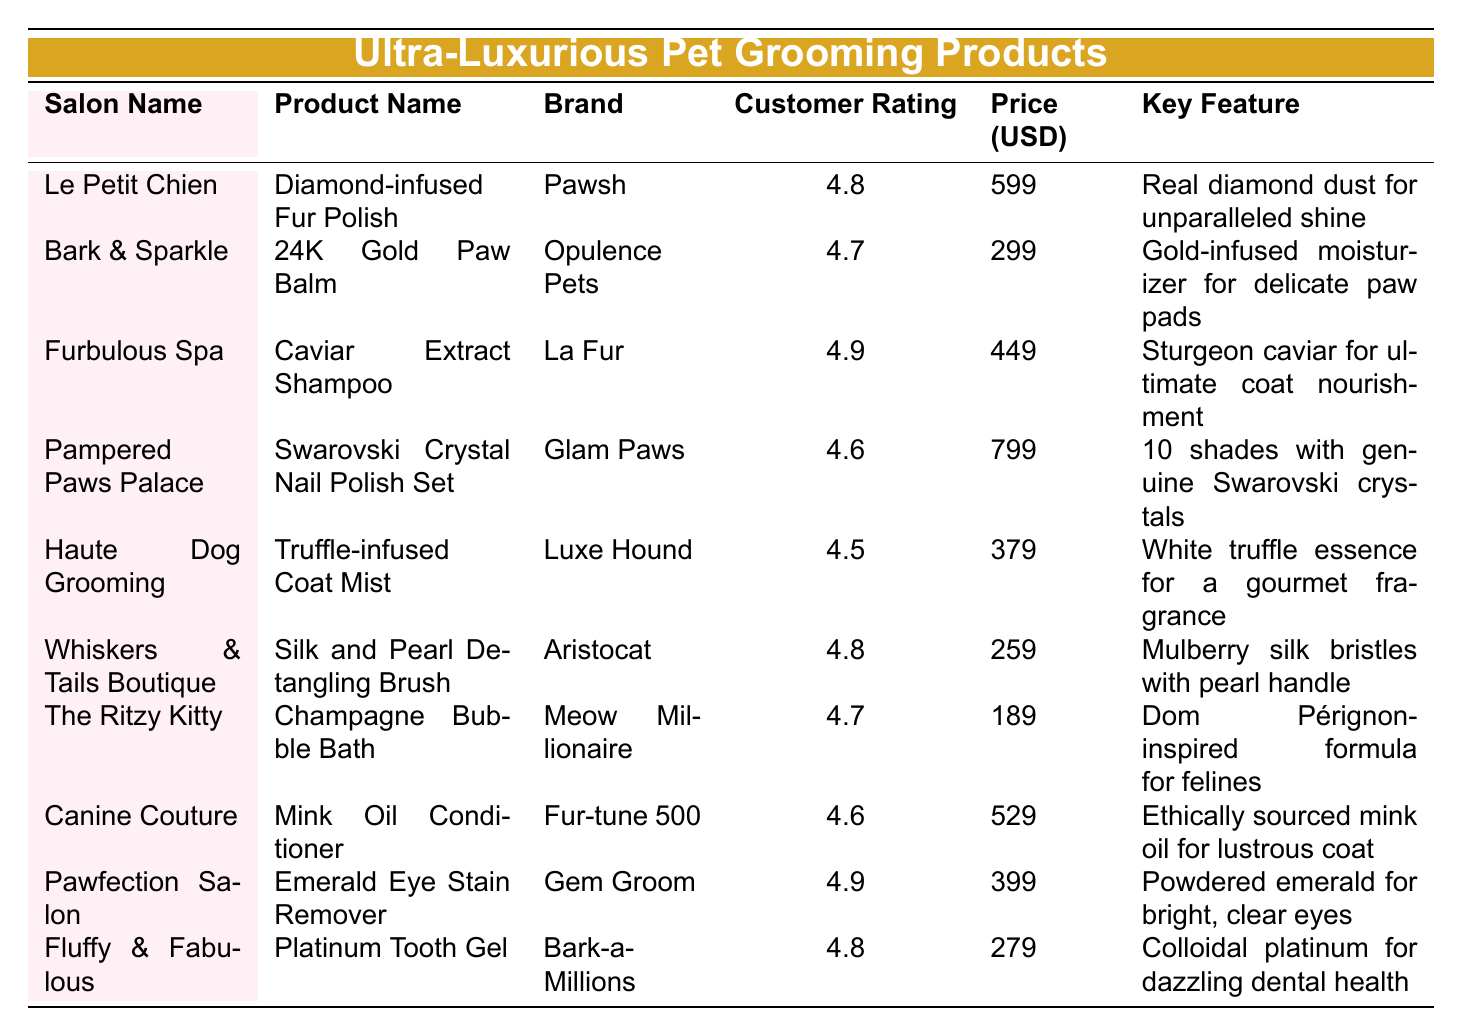What is the highest customer rating among the products? Scanning the "Customer Rating" column, the highest rating is found in the "Caviar Extract Shampoo" with a rating of 4.9.
Answer: 4.9 Which product is the most expensive? The "Swarovski Crystal Nail Polish Set" has the highest price listed at 799 USD in the "Price (USD)" column.
Answer: 799 How many products have a customer rating of 4.8 or higher? Counting the products with ratings of 4.8 or higher: "Diamond-infused Fur Polish", "Caviar Extract Shampoo", "Silk and Pearl Detangling Brush", "Emerald Eye Stain Remover", and "Platinum Tooth Gel" reaches a total of 5 products.
Answer: 5 What is the average price of all the products listed? Adding the prices (599 + 299 + 449 + 799 + 379 + 259 + 189 + 529 + 399 + 279 = 4,289) and dividing by the number of products (10) gives an average price of 428.9 USD.
Answer: 428.9 Is there a product from "Pawsh" salon rated below 4.6? The only product from "Pawsh" is "Diamond-infused Fur Polish", rated at 4.8, thus, there are no products by "Pawsh" rated below 4.6.
Answer: No Which brands have products rated 4.9, and what are their respective product names? The brands with products rated 4.9 are "La Fur" with "Caviar Extract Shampoo" and "Gem Groom" with "Emerald Eye Stain Remover".
Answer: La Fur (Caviar Extract Shampoo) and Gem Groom (Emerald Eye Stain Remover) What is the difference in price between the cheapest and the most expensive product? The cheapest product is "Champagne Bubble Bath" at 189 USD, and the most expensive is "Swarovski Crystal Nail Polish Set" at 799 USD. The price difference is calculated as 799 - 189 = 610 USD.
Answer: 610 If a customer wants to purchase all products with a customer rating of 4.7 or higher, how much would it cost? The products with ratings of 4.7 or higher are "Diamond-infused Fur Polish" (599), "Caviar Extract Shampoo" (449), "24K Gold Paw Balm" (299), "Swarovski Crystal Nail Polish Set" (799), "Silk and Pearl Detangling Brush" (259), "Champagne Bubble Bath" (189), "Emerald Eye Stain Remover" (399), and "Platinum Tooth Gel" (279). Adding these gives a total of 2,896 USD.
Answer: 2896 Does "Furbulous Spa" have a product with the best customer rating? Yes, "Furbulous Spa" has "Caviar Extract Shampoo" with a customer rating of 4.9, which is the highest rating in the table.
Answer: Yes What is the key feature associated with the "Mink Oil Conditioner"? The "Mink Oil Conditioner" from "Fur-tune 500" has the key feature of "Ethically sourced mink oil for lustrous coat".
Answer: Ethically sourced mink oil for lustrous coat 